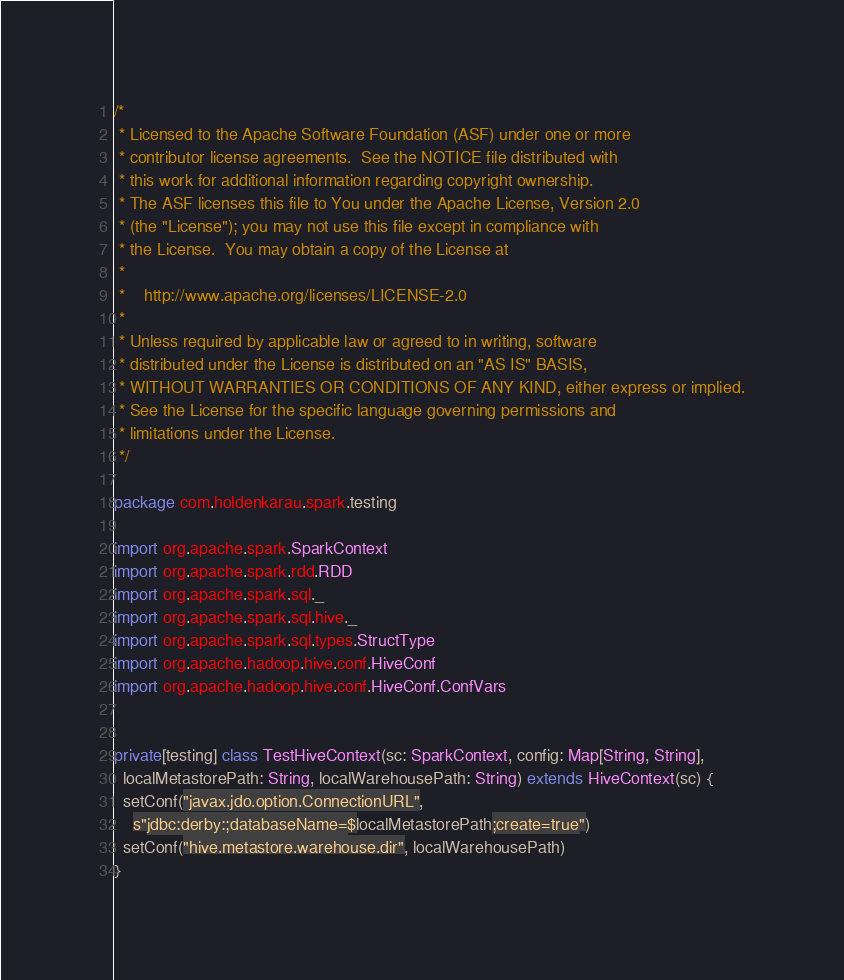Convert code to text. <code><loc_0><loc_0><loc_500><loc_500><_Scala_>/*
 * Licensed to the Apache Software Foundation (ASF) under one or more
 * contributor license agreements.  See the NOTICE file distributed with
 * this work for additional information regarding copyright ownership.
 * The ASF licenses this file to You under the Apache License, Version 2.0
 * (the "License"); you may not use this file except in compliance with
 * the License.  You may obtain a copy of the License at
 *
 *    http://www.apache.org/licenses/LICENSE-2.0
 *
 * Unless required by applicable law or agreed to in writing, software
 * distributed under the License is distributed on an "AS IS" BASIS,
 * WITHOUT WARRANTIES OR CONDITIONS OF ANY KIND, either express or implied.
 * See the License for the specific language governing permissions and
 * limitations under the License.
 */

package com.holdenkarau.spark.testing

import org.apache.spark.SparkContext
import org.apache.spark.rdd.RDD
import org.apache.spark.sql._
import org.apache.spark.sql.hive._
import org.apache.spark.sql.types.StructType
import org.apache.hadoop.hive.conf.HiveConf
import org.apache.hadoop.hive.conf.HiveConf.ConfVars


private[testing] class TestHiveContext(sc: SparkContext, config: Map[String, String],
  localMetastorePath: String, localWarehousePath: String) extends HiveContext(sc) {
  setConf("javax.jdo.option.ConnectionURL",
    s"jdbc:derby:;databaseName=$localMetastorePath;create=true")
  setConf("hive.metastore.warehouse.dir", localWarehousePath)
}
</code> 